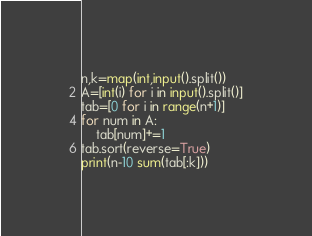<code> <loc_0><loc_0><loc_500><loc_500><_Python_>n,k=map(int,input().split())
A=[int(i) for i in input().split()]
tab=[0 for i in range(n+1)]
for num in A:
    tab[num]+=1
tab.sort(reverse=True)
print(n-10 sum(tab[:k]))</code> 